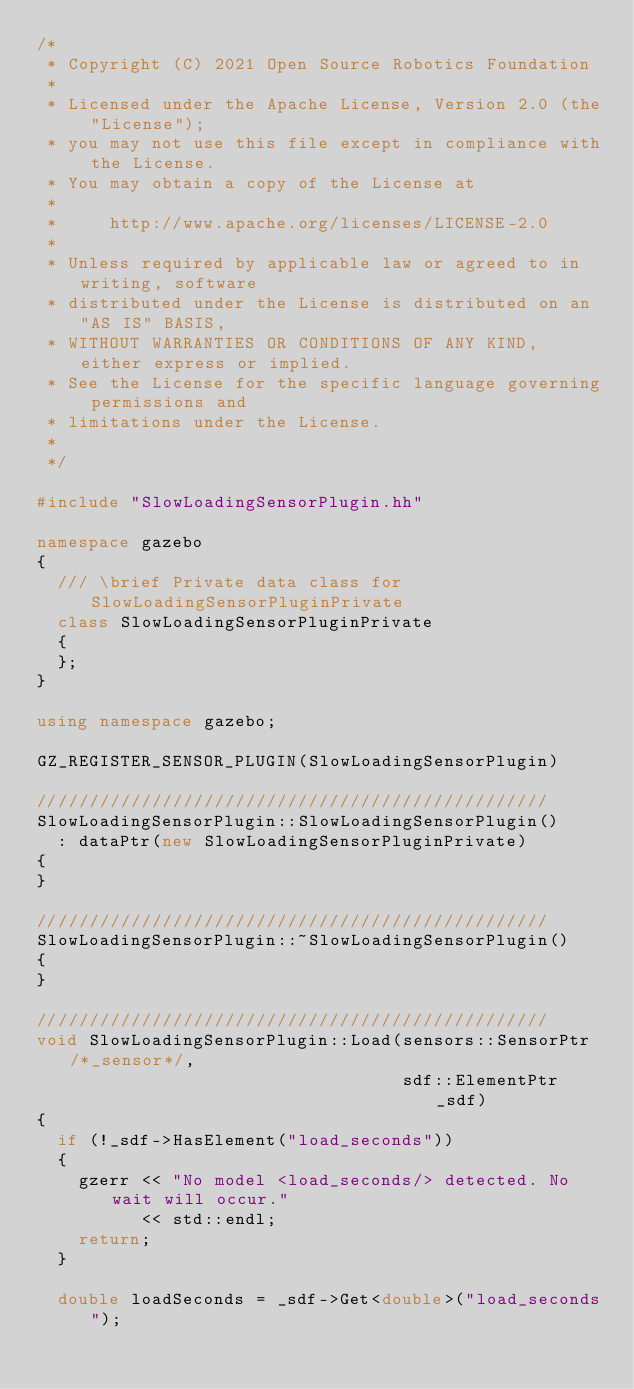Convert code to text. <code><loc_0><loc_0><loc_500><loc_500><_C++_>/*
 * Copyright (C) 2021 Open Source Robotics Foundation
 *
 * Licensed under the Apache License, Version 2.0 (the "License");
 * you may not use this file except in compliance with the License.
 * You may obtain a copy of the License at
 *
 *     http://www.apache.org/licenses/LICENSE-2.0
 *
 * Unless required by applicable law or agreed to in writing, software
 * distributed under the License is distributed on an "AS IS" BASIS,
 * WITHOUT WARRANTIES OR CONDITIONS OF ANY KIND, either express or implied.
 * See the License for the specific language governing permissions and
 * limitations under the License.
 *
 */

#include "SlowLoadingSensorPlugin.hh"

namespace gazebo
{
  /// \brief Private data class for SlowLoadingSensorPluginPrivate
  class SlowLoadingSensorPluginPrivate
  {
  };
}

using namespace gazebo;

GZ_REGISTER_SENSOR_PLUGIN(SlowLoadingSensorPlugin)

/////////////////////////////////////////////////
SlowLoadingSensorPlugin::SlowLoadingSensorPlugin()
  : dataPtr(new SlowLoadingSensorPluginPrivate)
{
}

/////////////////////////////////////////////////
SlowLoadingSensorPlugin::~SlowLoadingSensorPlugin()
{
}

/////////////////////////////////////////////////
void SlowLoadingSensorPlugin::Load(sensors::SensorPtr /*_sensor*/,
                                   sdf::ElementPtr _sdf)
{
  if (!_sdf->HasElement("load_seconds"))
  {
    gzerr << "No model <load_seconds/> detected. No wait will occur."
          << std::endl;
    return;
  }

  double loadSeconds = _sdf->Get<double>("load_seconds");
</code> 